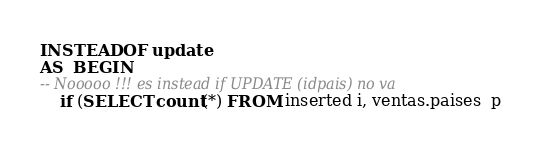<code> <loc_0><loc_0><loc_500><loc_500><_SQL_>INSTEAD OF update 
AS  BEGIN
-- Nooooo !!! es instead if UPDATE (idpais) no va
	if (SELECT count(*) FROM inserted i, ventas.paises  p </code> 